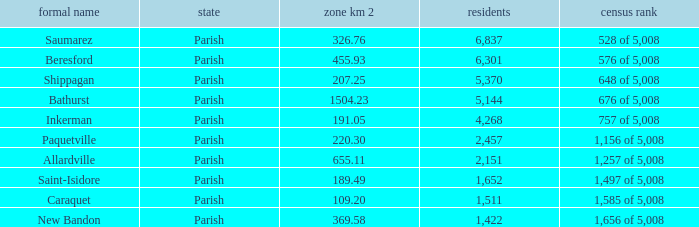What is the Area of the Allardville Parish with a Population smaller than 2,151? None. 